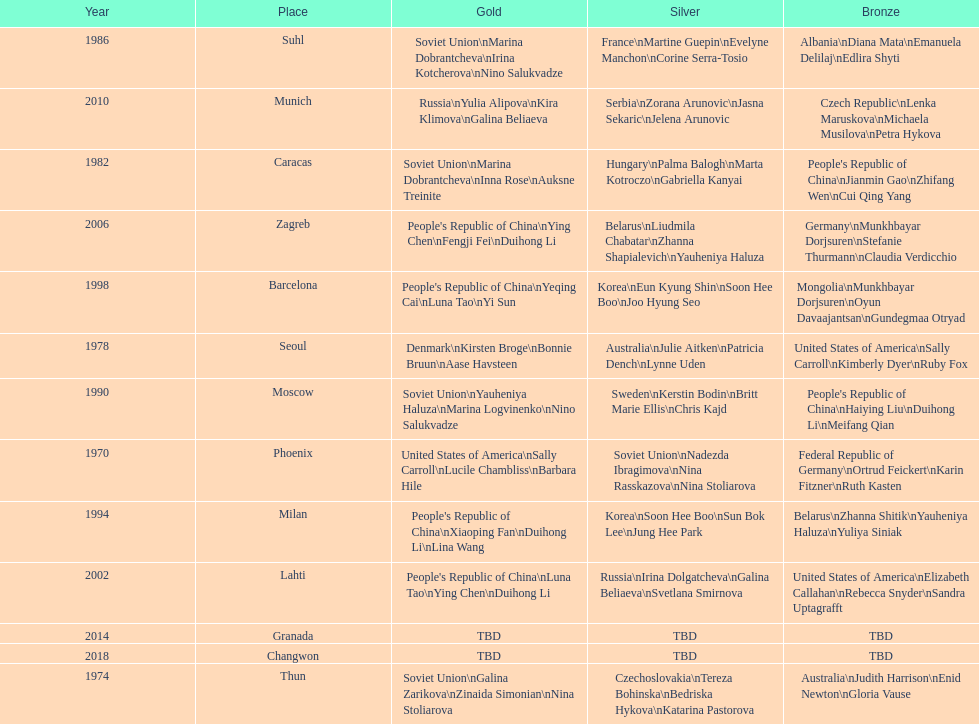What are the total number of times the soviet union is listed under the gold column? 4. 